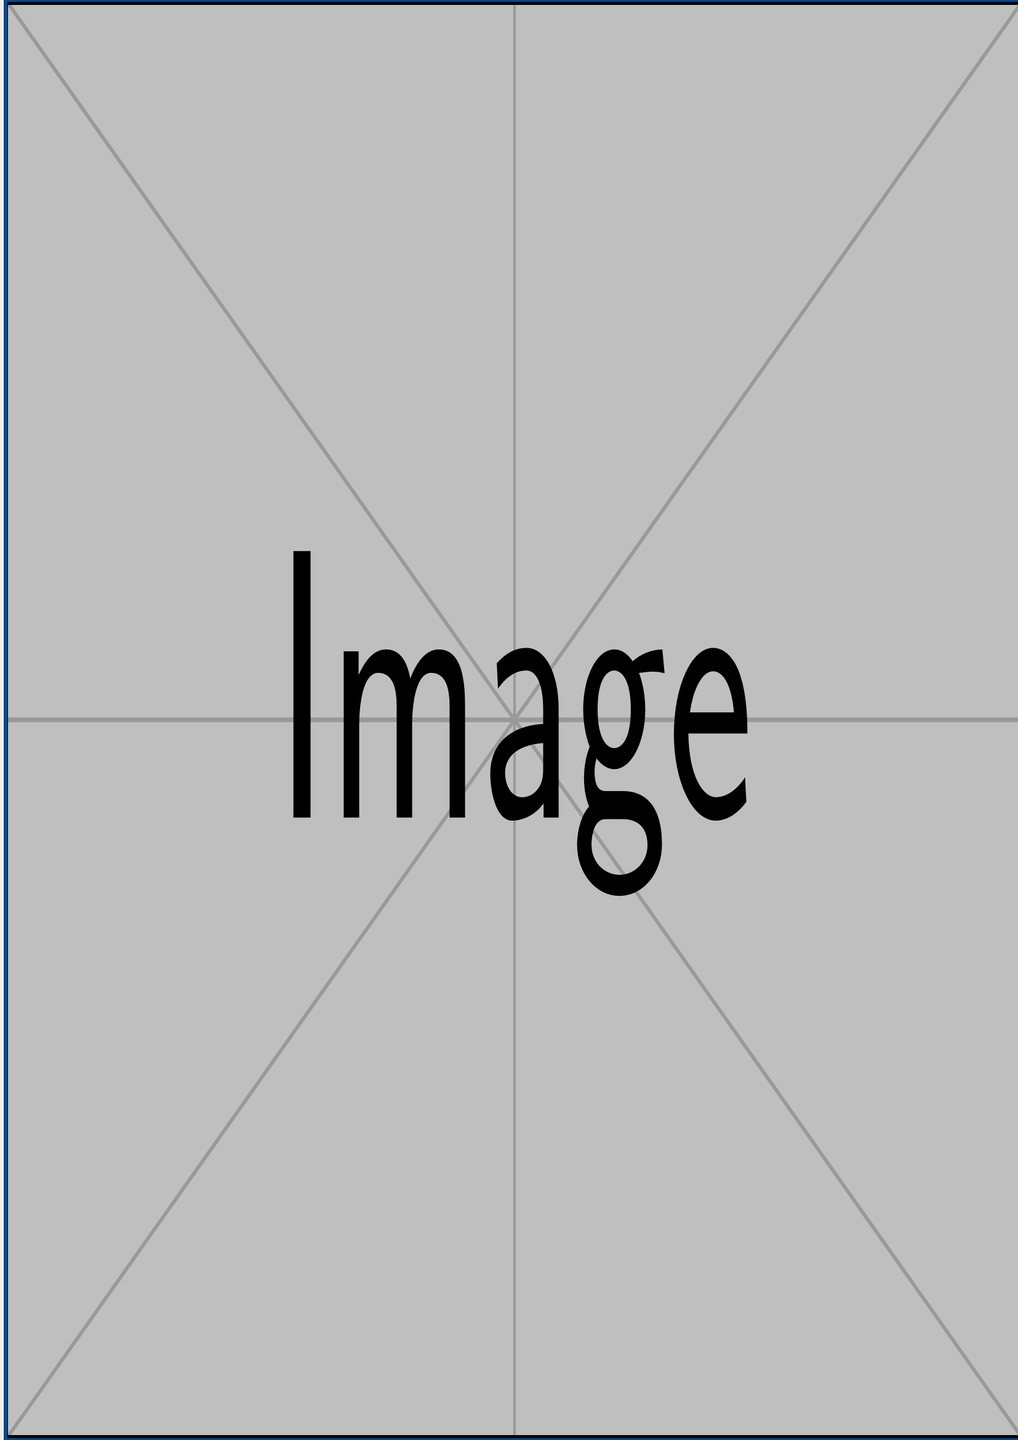What is the title of the book? The title is prominently featured at the top of the cover and reads "Blueprint for Peace."
Answer: Blueprint for Peace Who is the author of the book? The author is listed at the bottom of the cover as "Former Warlord Akande."
Answer: Former Warlord Akande What is the subtitle of the book? The subtitle follows the main title and states "Strategies for Regional Stability."
Answer: Strategies for Regional Stability What imagery is used on the cover? The cover includes elements like tactical maps and symbols of peace, such as olive branches and doves, represented visually.
Answer: Tactical maps and peace symbols What does the tagline suggest about the book's content? The tagline indicates a focus on transformation and the journey from conflict to peace, appealing to the forgiveness and reconciliation theme.
Answer: A Reformed Warlord's Journey to Peace and Prosperity How many colors are used in the design? The design employs three main colors - the background color, foreground color, and highlight color.
Answer: Three colors What kind of images are included on the cover? The cover features symbolic images that reinforce the themes of peace and stability, with depictions generally suggestive rather than literal.
Answer: Example images Where are the field operatives mentioned? The field operatives are referenced in the subtitle as contributors to the strategies discussed in the book.
Answer: with insights from Field Operatives 